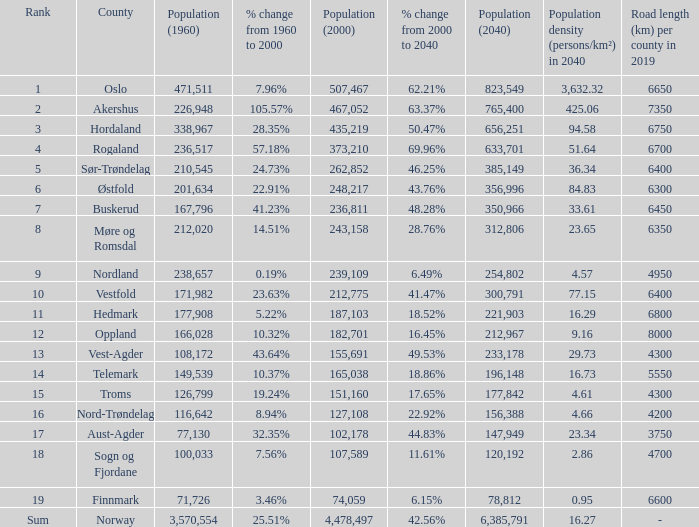What was Oslo's population in 1960, with a population of 507,467 in 2000? None. 